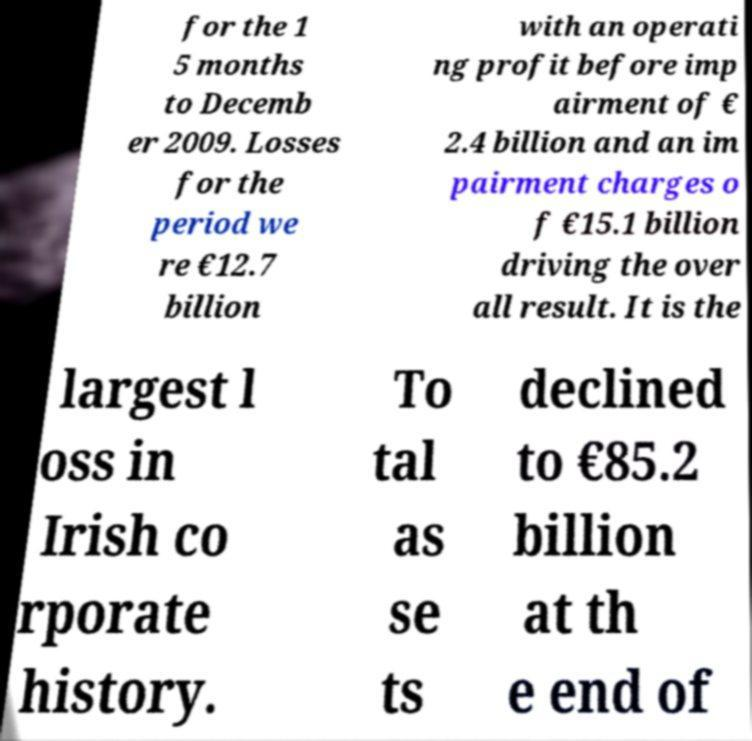For documentation purposes, I need the text within this image transcribed. Could you provide that? for the 1 5 months to Decemb er 2009. Losses for the period we re €12.7 billion with an operati ng profit before imp airment of € 2.4 billion and an im pairment charges o f €15.1 billion driving the over all result. It is the largest l oss in Irish co rporate history. To tal as se ts declined to €85.2 billion at th e end of 